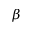Convert formula to latex. <formula><loc_0><loc_0><loc_500><loc_500>\beta</formula> 